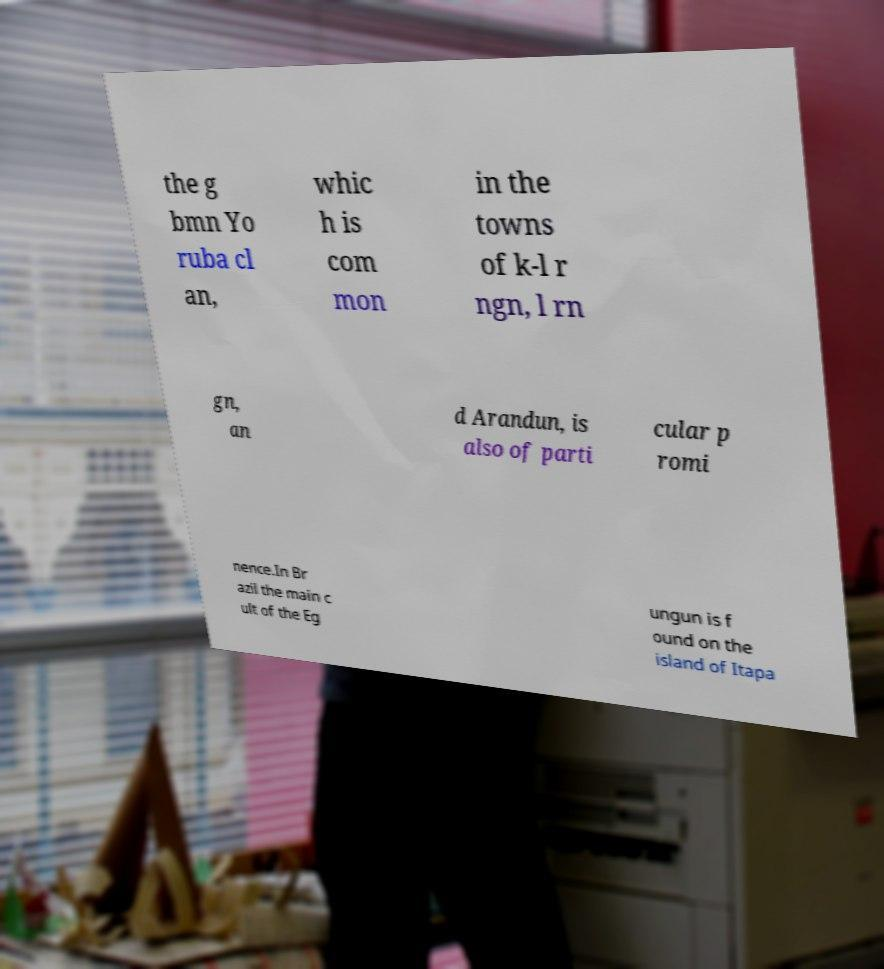Please read and relay the text visible in this image. What does it say? the g bmn Yo ruba cl an, whic h is com mon in the towns of k-l r ngn, l rn gn, an d Arandun, is also of parti cular p romi nence.In Br azil the main c ult of the Eg ungun is f ound on the island of Itapa 